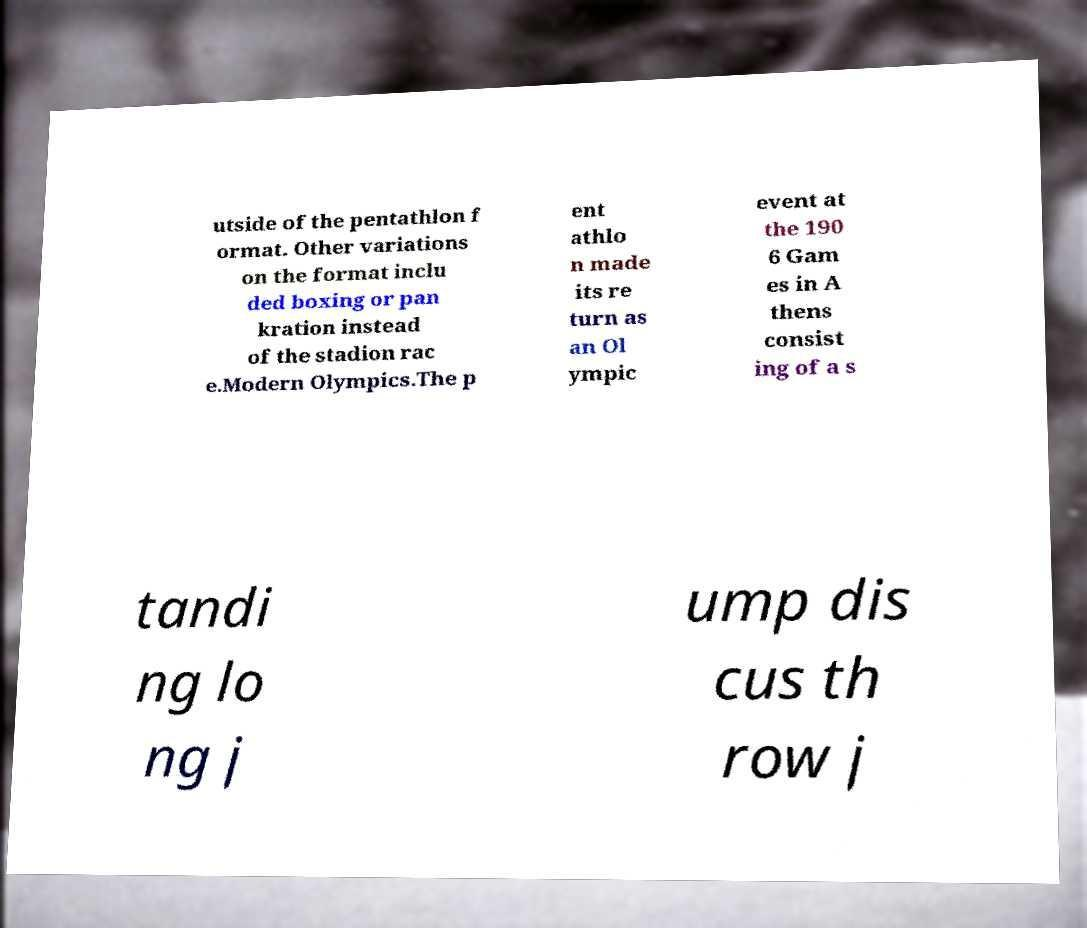Can you read and provide the text displayed in the image?This photo seems to have some interesting text. Can you extract and type it out for me? utside of the pentathlon f ormat. Other variations on the format inclu ded boxing or pan kration instead of the stadion rac e.Modern Olympics.The p ent athlo n made its re turn as an Ol ympic event at the 190 6 Gam es in A thens consist ing of a s tandi ng lo ng j ump dis cus th row j 